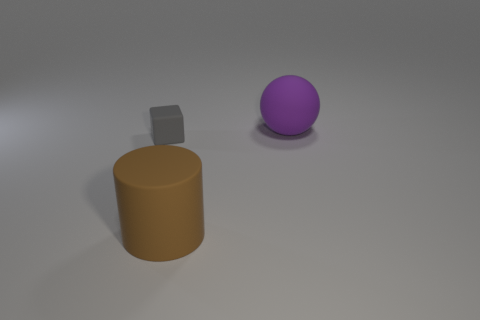Add 1 large objects. How many objects exist? 4 Subtract all blocks. How many objects are left? 2 Subtract 0 red blocks. How many objects are left? 3 Subtract all big blue cylinders. Subtract all gray objects. How many objects are left? 2 Add 2 matte balls. How many matte balls are left? 3 Add 1 yellow matte cylinders. How many yellow matte cylinders exist? 1 